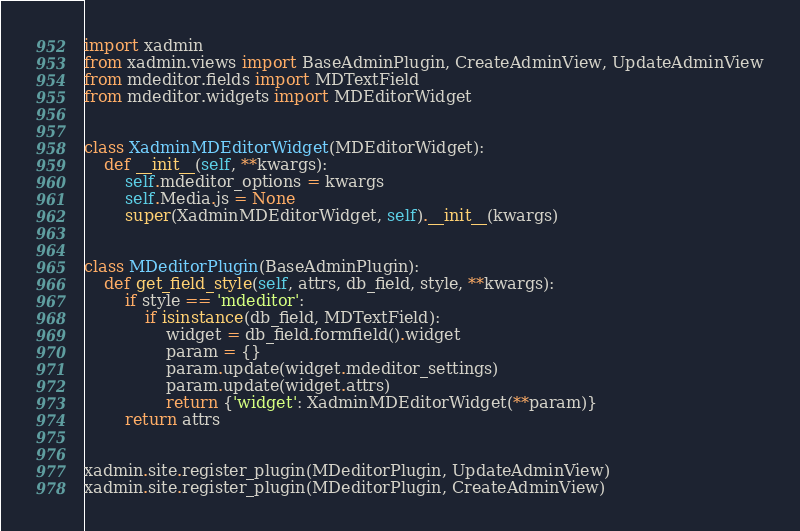Convert code to text. <code><loc_0><loc_0><loc_500><loc_500><_Python_>import xadmin
from xadmin.views import BaseAdminPlugin, CreateAdminView, UpdateAdminView
from mdeditor.fields import MDTextField
from mdeditor.widgets import MDEditorWidget


class XadminMDEditorWidget(MDEditorWidget):
    def __init__(self, **kwargs):
        self.mdeditor_options = kwargs
        self.Media.js = None
        super(XadminMDEditorWidget, self).__init__(kwargs)


class MDeditorPlugin(BaseAdminPlugin):
    def get_field_style(self, attrs, db_field, style, **kwargs):
        if style == 'mdeditor':
            if isinstance(db_field, MDTextField):
                widget = db_field.formfield().widget
                param = {}
                param.update(widget.mdeditor_settings)
                param.update(widget.attrs)
                return {'widget': XadminMDEditorWidget(**param)}
        return attrs


xadmin.site.register_plugin(MDeditorPlugin, UpdateAdminView)
xadmin.site.register_plugin(MDeditorPlugin, CreateAdminView)
</code> 